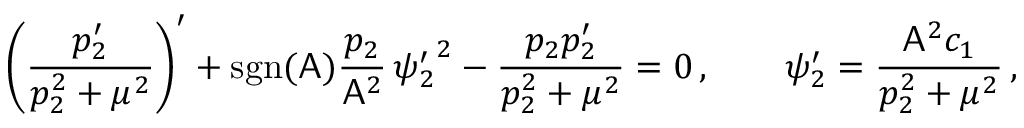Convert formula to latex. <formula><loc_0><loc_0><loc_500><loc_500>\left ( \frac { p _ { 2 } ^ { \prime } } { p _ { 2 } ^ { 2 } + \mu ^ { 2 } } \right ) ^ { \prime } + s g n ( A ) \frac { p _ { 2 } } { A ^ { 2 } } \, { \psi _ { 2 } ^ { \prime } } ^ { 2 } - \frac { p _ { 2 } p _ { 2 } ^ { \prime } } { p _ { 2 } ^ { 2 } + \mu ^ { 2 } } = 0 \, , \quad \psi _ { 2 } ^ { \prime } = \frac { A ^ { 2 } c _ { 1 } } { p _ { 2 } ^ { 2 } + \mu ^ { 2 } } \, ,</formula> 